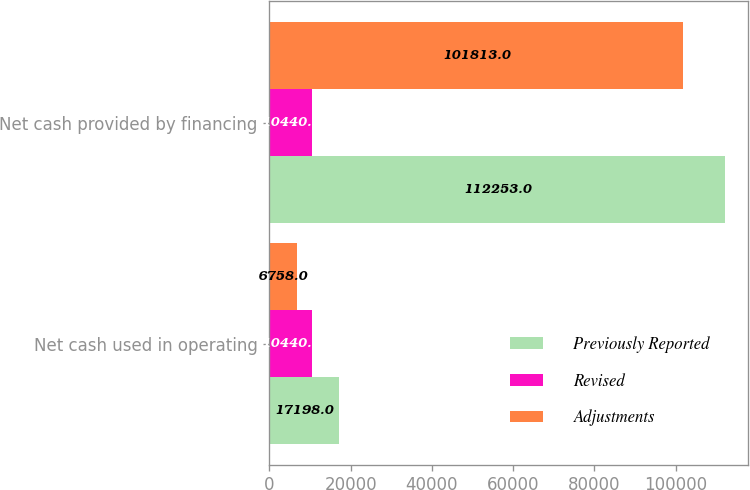Convert chart to OTSL. <chart><loc_0><loc_0><loc_500><loc_500><stacked_bar_chart><ecel><fcel>Net cash used in operating<fcel>Net cash provided by financing<nl><fcel>Previously Reported<fcel>17198<fcel>112253<nl><fcel>Revised<fcel>10440<fcel>10440<nl><fcel>Adjustments<fcel>6758<fcel>101813<nl></chart> 